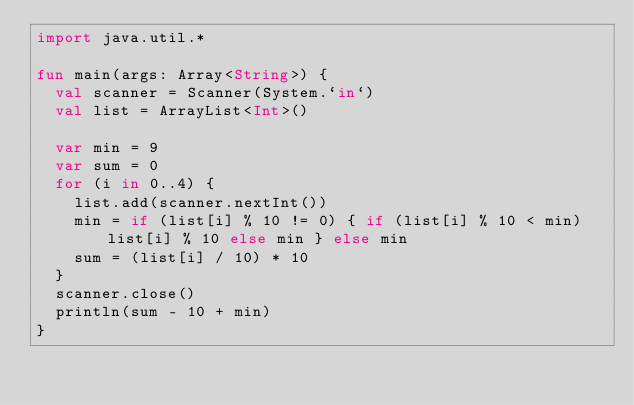Convert code to text. <code><loc_0><loc_0><loc_500><loc_500><_Kotlin_>import java.util.*

fun main(args: Array<String>) {
  val scanner = Scanner(System.`in`)
  val list = ArrayList<Int>()

  var min = 9
  var sum = 0
  for (i in 0..4) {
    list.add(scanner.nextInt())
    min = if (list[i] % 10 != 0) { if (list[i] % 10 < min) list[i] % 10 else min } else min
    sum = (list[i] / 10) * 10
  }
  scanner.close()
  println(sum - 10 + min)
}
</code> 